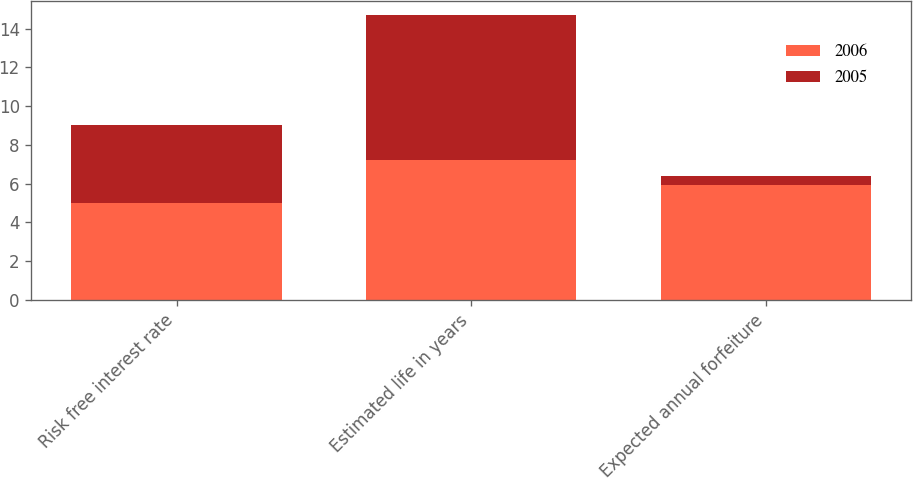Convert chart to OTSL. <chart><loc_0><loc_0><loc_500><loc_500><stacked_bar_chart><ecel><fcel>Risk free interest rate<fcel>Estimated life in years<fcel>Expected annual forfeiture<nl><fcel>2006<fcel>5<fcel>7.2<fcel>5.9<nl><fcel>2005<fcel>4<fcel>7.5<fcel>0.5<nl></chart> 